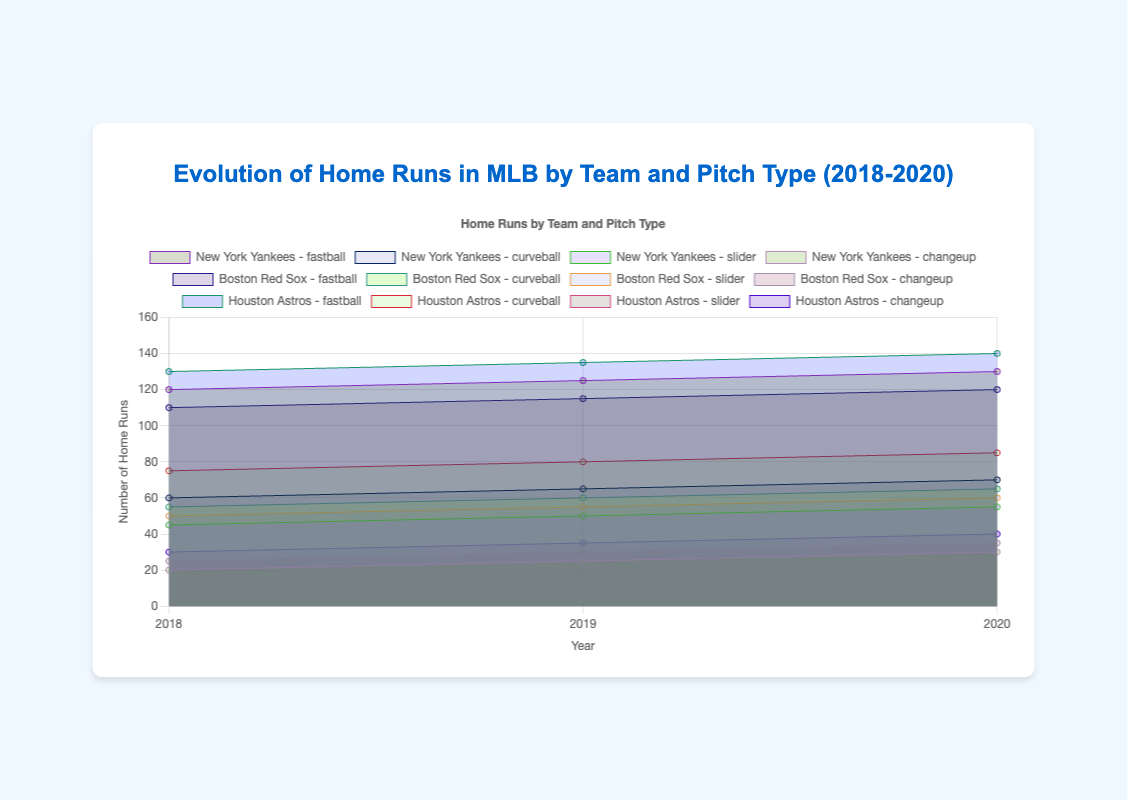How many home runs did the New York Yankees hit on fastballs in 2020? To answer this question, locate the area for the New York Yankees in 2020 and identify the section representing fastballs. The figure shows 130 home runs.
Answer: 130 Which team hit the most home runs off curveballs in 2019? Compare the curveball sections of each team in 2019. Houston Astros hit the highest, marked at 80 home runs.
Answer: Houston Astros What's the trend of home runs hit by the Boston Red Sox on sliders between 2018 and 2020? Observe the Boston Red Sox's slider areas from 2018 to 2020. Home runs on sliders increase from 50 in 2018 to 55 in 2019 and 60 in 2020.
Answer: Increasing What is the total number of home runs hit by the Houston Astros off changeups from 2018 to 2020? Add the changeup segments for the Houston Astros over the years 2018 (30), 2019 (35), and 2020 (40). 30 + 35 + 40 = 105.
Answer: 105 Compare the total home runs hit on fastballs by the New York Yankees and Boston Red Sox in 2018. Which team hit more? For 2018, sum the fastball regions: New York Yankees at 120 and Boston Red Sox at 110. The Yankees hit more.
Answer: New York Yankees What's the difference in the number of home runs hit by the New York Yankees on curveballs between 2018 and 2019? Subtract the curveball areas for the Yankees: 65 in 2019 minus 60 in 2018. 65 - 60 = 5.
Answer: 5 Which pitch type consistently had the highest number of home runs across all teams from 2018 to 2020? Look across all teams and years; the fastball regions consistently have the largest areas.
Answer: Fastball How many total home runs did the Boston Red Sox hit across all pitch types in 2020? Sum the different pitch areas in 2020 for Boston Red Sox: 120 (fastball) + 65 (curveball) + 60 (slider) + 35 (changeup). Total is 280.
Answer: 280 